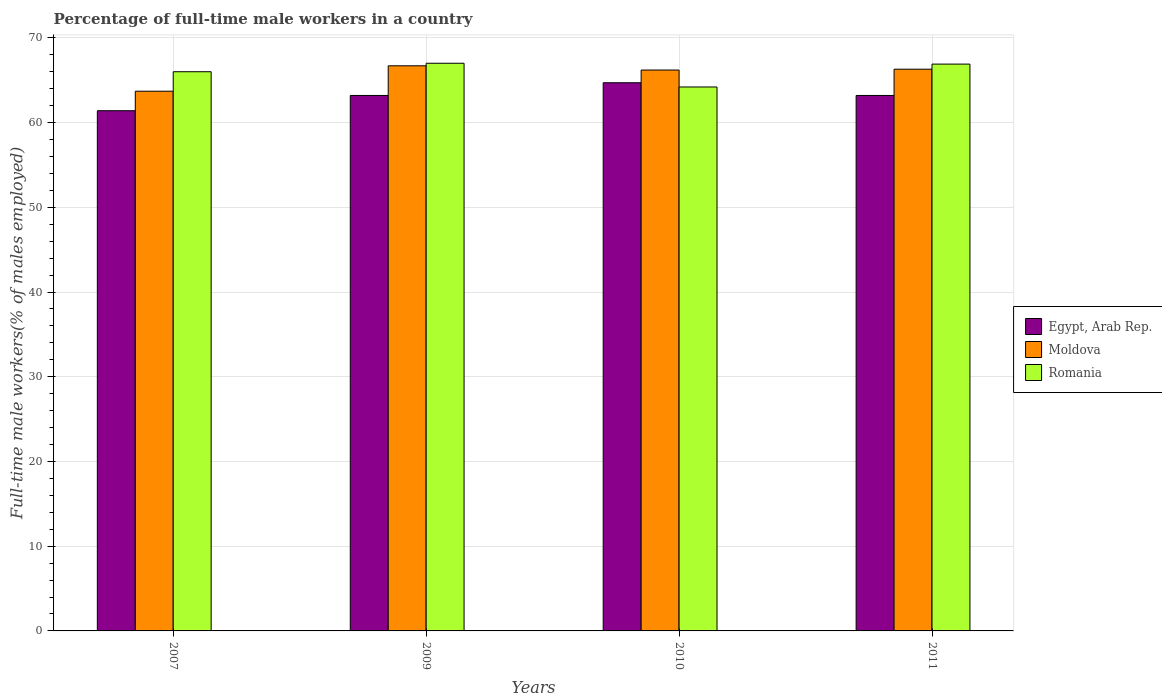How many different coloured bars are there?
Give a very brief answer. 3. How many groups of bars are there?
Your response must be concise. 4. Are the number of bars per tick equal to the number of legend labels?
Offer a terse response. Yes. Are the number of bars on each tick of the X-axis equal?
Your answer should be very brief. Yes. How many bars are there on the 1st tick from the left?
Your answer should be very brief. 3. What is the label of the 1st group of bars from the left?
Keep it short and to the point. 2007. In how many cases, is the number of bars for a given year not equal to the number of legend labels?
Give a very brief answer. 0. What is the percentage of full-time male workers in Romania in 2010?
Your answer should be very brief. 64.2. Across all years, what is the maximum percentage of full-time male workers in Egypt, Arab Rep.?
Give a very brief answer. 64.7. Across all years, what is the minimum percentage of full-time male workers in Romania?
Give a very brief answer. 64.2. In which year was the percentage of full-time male workers in Moldova maximum?
Make the answer very short. 2009. What is the total percentage of full-time male workers in Egypt, Arab Rep. in the graph?
Provide a short and direct response. 252.5. What is the difference between the percentage of full-time male workers in Egypt, Arab Rep. in 2009 and that in 2010?
Keep it short and to the point. -1.5. What is the difference between the percentage of full-time male workers in Egypt, Arab Rep. in 2011 and the percentage of full-time male workers in Romania in 2009?
Your response must be concise. -3.8. What is the average percentage of full-time male workers in Romania per year?
Offer a very short reply. 66.02. In the year 2010, what is the difference between the percentage of full-time male workers in Moldova and percentage of full-time male workers in Romania?
Keep it short and to the point. 2. In how many years, is the percentage of full-time male workers in Egypt, Arab Rep. greater than 24 %?
Your answer should be very brief. 4. What is the ratio of the percentage of full-time male workers in Romania in 2009 to that in 2010?
Ensure brevity in your answer.  1.04. Is the difference between the percentage of full-time male workers in Moldova in 2007 and 2009 greater than the difference between the percentage of full-time male workers in Romania in 2007 and 2009?
Your answer should be compact. No. What is the difference between the highest and the second highest percentage of full-time male workers in Egypt, Arab Rep.?
Your answer should be very brief. 1.5. What is the difference between the highest and the lowest percentage of full-time male workers in Romania?
Ensure brevity in your answer.  2.8. What does the 1st bar from the left in 2009 represents?
Offer a terse response. Egypt, Arab Rep. What does the 1st bar from the right in 2007 represents?
Give a very brief answer. Romania. How many bars are there?
Keep it short and to the point. 12. Are all the bars in the graph horizontal?
Offer a terse response. No. How many years are there in the graph?
Make the answer very short. 4. What is the difference between two consecutive major ticks on the Y-axis?
Make the answer very short. 10. Are the values on the major ticks of Y-axis written in scientific E-notation?
Your answer should be very brief. No. Does the graph contain any zero values?
Make the answer very short. No. Where does the legend appear in the graph?
Keep it short and to the point. Center right. What is the title of the graph?
Keep it short and to the point. Percentage of full-time male workers in a country. Does "Suriname" appear as one of the legend labels in the graph?
Your answer should be very brief. No. What is the label or title of the X-axis?
Give a very brief answer. Years. What is the label or title of the Y-axis?
Give a very brief answer. Full-time male workers(% of males employed). What is the Full-time male workers(% of males employed) of Egypt, Arab Rep. in 2007?
Offer a terse response. 61.4. What is the Full-time male workers(% of males employed) in Moldova in 2007?
Keep it short and to the point. 63.7. What is the Full-time male workers(% of males employed) of Egypt, Arab Rep. in 2009?
Give a very brief answer. 63.2. What is the Full-time male workers(% of males employed) of Moldova in 2009?
Ensure brevity in your answer.  66.7. What is the Full-time male workers(% of males employed) of Romania in 2009?
Keep it short and to the point. 67. What is the Full-time male workers(% of males employed) in Egypt, Arab Rep. in 2010?
Your response must be concise. 64.7. What is the Full-time male workers(% of males employed) of Moldova in 2010?
Keep it short and to the point. 66.2. What is the Full-time male workers(% of males employed) of Romania in 2010?
Your response must be concise. 64.2. What is the Full-time male workers(% of males employed) in Egypt, Arab Rep. in 2011?
Your response must be concise. 63.2. What is the Full-time male workers(% of males employed) of Moldova in 2011?
Offer a terse response. 66.3. What is the Full-time male workers(% of males employed) of Romania in 2011?
Provide a short and direct response. 66.9. Across all years, what is the maximum Full-time male workers(% of males employed) in Egypt, Arab Rep.?
Your answer should be very brief. 64.7. Across all years, what is the maximum Full-time male workers(% of males employed) in Moldova?
Offer a terse response. 66.7. Across all years, what is the minimum Full-time male workers(% of males employed) of Egypt, Arab Rep.?
Provide a short and direct response. 61.4. Across all years, what is the minimum Full-time male workers(% of males employed) in Moldova?
Your answer should be compact. 63.7. Across all years, what is the minimum Full-time male workers(% of males employed) of Romania?
Your answer should be compact. 64.2. What is the total Full-time male workers(% of males employed) in Egypt, Arab Rep. in the graph?
Offer a terse response. 252.5. What is the total Full-time male workers(% of males employed) in Moldova in the graph?
Offer a very short reply. 262.9. What is the total Full-time male workers(% of males employed) of Romania in the graph?
Your answer should be very brief. 264.1. What is the difference between the Full-time male workers(% of males employed) of Egypt, Arab Rep. in 2007 and that in 2009?
Make the answer very short. -1.8. What is the difference between the Full-time male workers(% of males employed) of Romania in 2007 and that in 2009?
Your response must be concise. -1. What is the difference between the Full-time male workers(% of males employed) of Moldova in 2007 and that in 2010?
Offer a very short reply. -2.5. What is the difference between the Full-time male workers(% of males employed) in Egypt, Arab Rep. in 2007 and that in 2011?
Offer a terse response. -1.8. What is the difference between the Full-time male workers(% of males employed) of Moldova in 2007 and that in 2011?
Your response must be concise. -2.6. What is the difference between the Full-time male workers(% of males employed) of Romania in 2007 and that in 2011?
Your answer should be very brief. -0.9. What is the difference between the Full-time male workers(% of males employed) in Moldova in 2009 and that in 2010?
Offer a terse response. 0.5. What is the difference between the Full-time male workers(% of males employed) of Romania in 2009 and that in 2010?
Provide a short and direct response. 2.8. What is the difference between the Full-time male workers(% of males employed) in Egypt, Arab Rep. in 2009 and that in 2011?
Offer a terse response. 0. What is the difference between the Full-time male workers(% of males employed) of Romania in 2009 and that in 2011?
Offer a terse response. 0.1. What is the difference between the Full-time male workers(% of males employed) in Egypt, Arab Rep. in 2010 and that in 2011?
Offer a very short reply. 1.5. What is the difference between the Full-time male workers(% of males employed) of Moldova in 2010 and that in 2011?
Your answer should be very brief. -0.1. What is the difference between the Full-time male workers(% of males employed) of Egypt, Arab Rep. in 2007 and the Full-time male workers(% of males employed) of Romania in 2009?
Provide a succinct answer. -5.6. What is the difference between the Full-time male workers(% of males employed) of Moldova in 2007 and the Full-time male workers(% of males employed) of Romania in 2009?
Provide a succinct answer. -3.3. What is the difference between the Full-time male workers(% of males employed) of Moldova in 2007 and the Full-time male workers(% of males employed) of Romania in 2010?
Make the answer very short. -0.5. What is the difference between the Full-time male workers(% of males employed) in Egypt, Arab Rep. in 2007 and the Full-time male workers(% of males employed) in Moldova in 2011?
Your response must be concise. -4.9. What is the difference between the Full-time male workers(% of males employed) of Egypt, Arab Rep. in 2007 and the Full-time male workers(% of males employed) of Romania in 2011?
Provide a short and direct response. -5.5. What is the difference between the Full-time male workers(% of males employed) of Moldova in 2007 and the Full-time male workers(% of males employed) of Romania in 2011?
Make the answer very short. -3.2. What is the difference between the Full-time male workers(% of males employed) of Egypt, Arab Rep. in 2009 and the Full-time male workers(% of males employed) of Moldova in 2010?
Your answer should be compact. -3. What is the difference between the Full-time male workers(% of males employed) of Egypt, Arab Rep. in 2009 and the Full-time male workers(% of males employed) of Romania in 2010?
Ensure brevity in your answer.  -1. What is the difference between the Full-time male workers(% of males employed) in Moldova in 2009 and the Full-time male workers(% of males employed) in Romania in 2010?
Keep it short and to the point. 2.5. What is the difference between the Full-time male workers(% of males employed) in Egypt, Arab Rep. in 2009 and the Full-time male workers(% of males employed) in Romania in 2011?
Your response must be concise. -3.7. What is the difference between the Full-time male workers(% of males employed) of Egypt, Arab Rep. in 2010 and the Full-time male workers(% of males employed) of Moldova in 2011?
Make the answer very short. -1.6. What is the difference between the Full-time male workers(% of males employed) in Moldova in 2010 and the Full-time male workers(% of males employed) in Romania in 2011?
Give a very brief answer. -0.7. What is the average Full-time male workers(% of males employed) in Egypt, Arab Rep. per year?
Your response must be concise. 63.12. What is the average Full-time male workers(% of males employed) of Moldova per year?
Offer a very short reply. 65.72. What is the average Full-time male workers(% of males employed) in Romania per year?
Provide a succinct answer. 66.03. In the year 2007, what is the difference between the Full-time male workers(% of males employed) of Egypt, Arab Rep. and Full-time male workers(% of males employed) of Romania?
Your response must be concise. -4.6. In the year 2010, what is the difference between the Full-time male workers(% of males employed) in Egypt, Arab Rep. and Full-time male workers(% of males employed) in Romania?
Ensure brevity in your answer.  0.5. In the year 2010, what is the difference between the Full-time male workers(% of males employed) in Moldova and Full-time male workers(% of males employed) in Romania?
Make the answer very short. 2. In the year 2011, what is the difference between the Full-time male workers(% of males employed) in Egypt, Arab Rep. and Full-time male workers(% of males employed) in Moldova?
Offer a terse response. -3.1. In the year 2011, what is the difference between the Full-time male workers(% of males employed) in Egypt, Arab Rep. and Full-time male workers(% of males employed) in Romania?
Make the answer very short. -3.7. What is the ratio of the Full-time male workers(% of males employed) of Egypt, Arab Rep. in 2007 to that in 2009?
Your answer should be compact. 0.97. What is the ratio of the Full-time male workers(% of males employed) of Moldova in 2007 to that in 2009?
Offer a very short reply. 0.95. What is the ratio of the Full-time male workers(% of males employed) in Romania in 2007 to that in 2009?
Provide a succinct answer. 0.99. What is the ratio of the Full-time male workers(% of males employed) in Egypt, Arab Rep. in 2007 to that in 2010?
Your answer should be compact. 0.95. What is the ratio of the Full-time male workers(% of males employed) of Moldova in 2007 to that in 2010?
Your answer should be compact. 0.96. What is the ratio of the Full-time male workers(% of males employed) of Romania in 2007 to that in 2010?
Make the answer very short. 1.03. What is the ratio of the Full-time male workers(% of males employed) in Egypt, Arab Rep. in 2007 to that in 2011?
Your answer should be compact. 0.97. What is the ratio of the Full-time male workers(% of males employed) of Moldova in 2007 to that in 2011?
Your answer should be compact. 0.96. What is the ratio of the Full-time male workers(% of males employed) in Romania in 2007 to that in 2011?
Keep it short and to the point. 0.99. What is the ratio of the Full-time male workers(% of males employed) of Egypt, Arab Rep. in 2009 to that in 2010?
Provide a short and direct response. 0.98. What is the ratio of the Full-time male workers(% of males employed) in Moldova in 2009 to that in 2010?
Provide a short and direct response. 1.01. What is the ratio of the Full-time male workers(% of males employed) of Romania in 2009 to that in 2010?
Your answer should be compact. 1.04. What is the ratio of the Full-time male workers(% of males employed) in Egypt, Arab Rep. in 2010 to that in 2011?
Your response must be concise. 1.02. What is the ratio of the Full-time male workers(% of males employed) of Romania in 2010 to that in 2011?
Give a very brief answer. 0.96. What is the difference between the highest and the second highest Full-time male workers(% of males employed) of Egypt, Arab Rep.?
Offer a very short reply. 1.5. What is the difference between the highest and the second highest Full-time male workers(% of males employed) in Moldova?
Your answer should be compact. 0.4. What is the difference between the highest and the second highest Full-time male workers(% of males employed) of Romania?
Offer a very short reply. 0.1. What is the difference between the highest and the lowest Full-time male workers(% of males employed) in Moldova?
Provide a short and direct response. 3. 